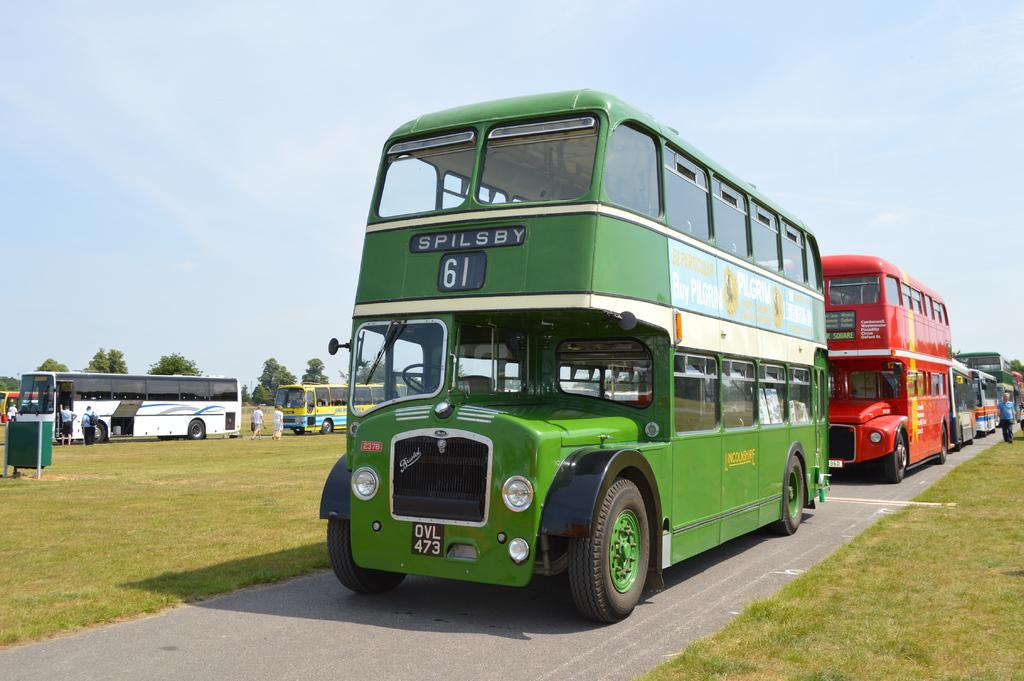<image>
Render a clear and concise summary of the photo. Bus route 61 is going to Spilsby according to the sign on this green bus. 